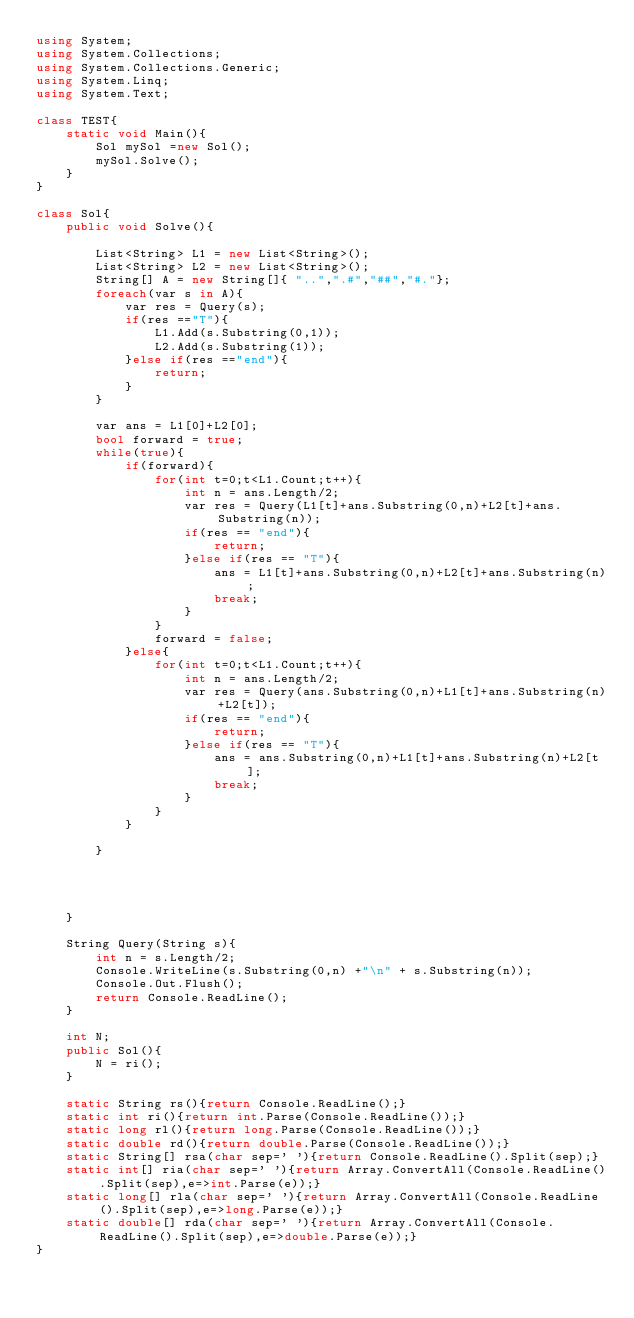<code> <loc_0><loc_0><loc_500><loc_500><_C#_>using System;
using System.Collections;
using System.Collections.Generic;
using System.Linq;
using System.Text;

class TEST{
	static void Main(){
		Sol mySol =new Sol();
		mySol.Solve();
	}
}

class Sol{
	public void Solve(){
		
		List<String> L1 = new List<String>();
		List<String> L2 = new List<String>();
		String[] A = new String[]{ "..",".#","##","#."};
		foreach(var s in A){
			var res = Query(s);
			if(res =="T"){
				L1.Add(s.Substring(0,1));
				L2.Add(s.Substring(1));
			}else if(res =="end"){
				return;
			}
		}
		
		var ans = L1[0]+L2[0];
		bool forward = true;
		while(true){
			if(forward){
				for(int t=0;t<L1.Count;t++){
					int n = ans.Length/2;
					var res = Query(L1[t]+ans.Substring(0,n)+L2[t]+ans.Substring(n));
					if(res == "end"){
						return;
					}else if(res == "T"){
						ans = L1[t]+ans.Substring(0,n)+L2[t]+ans.Substring(n);
						break;
					}
				}
				forward = false;
			}else{
				for(int t=0;t<L1.Count;t++){
					int n = ans.Length/2;
					var res = Query(ans.Substring(0,n)+L1[t]+ans.Substring(n)+L2[t]);
					if(res == "end"){
						return;
					}else if(res == "T"){
						ans = ans.Substring(0,n)+L1[t]+ans.Substring(n)+L2[t];
						break;
					}
				}
			}
			
		}
		
		
		
		
	}
	
	String Query(String s){
		int n = s.Length/2;
		Console.WriteLine(s.Substring(0,n) +"\n" + s.Substring(n));
		Console.Out.Flush();
		return Console.ReadLine();
	}
	
	int N;
	public Sol(){
		N = ri();
	}

	static String rs(){return Console.ReadLine();}
	static int ri(){return int.Parse(Console.ReadLine());}
	static long rl(){return long.Parse(Console.ReadLine());}
	static double rd(){return double.Parse(Console.ReadLine());}
	static String[] rsa(char sep=' '){return Console.ReadLine().Split(sep);}
	static int[] ria(char sep=' '){return Array.ConvertAll(Console.ReadLine().Split(sep),e=>int.Parse(e));}
	static long[] rla(char sep=' '){return Array.ConvertAll(Console.ReadLine().Split(sep),e=>long.Parse(e));}
	static double[] rda(char sep=' '){return Array.ConvertAll(Console.ReadLine().Split(sep),e=>double.Parse(e));}
}
</code> 